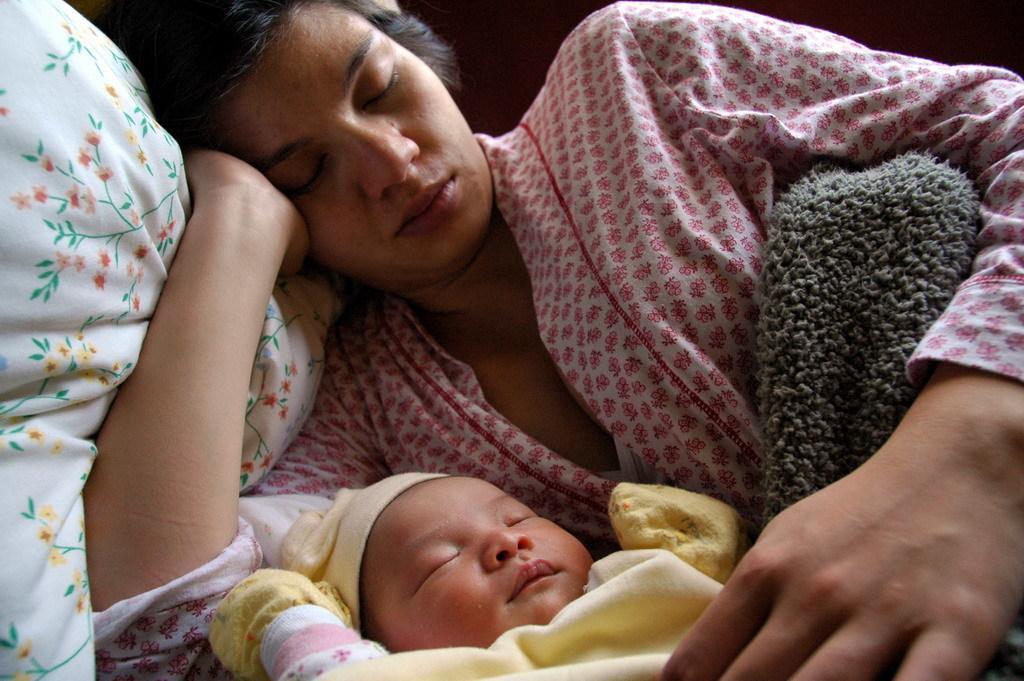Describe this image in one or two sentences. There is a lady sleeping on a pillow and having blanket on her. Near to her there is a baby wearing gloves and cap is sleeping. 